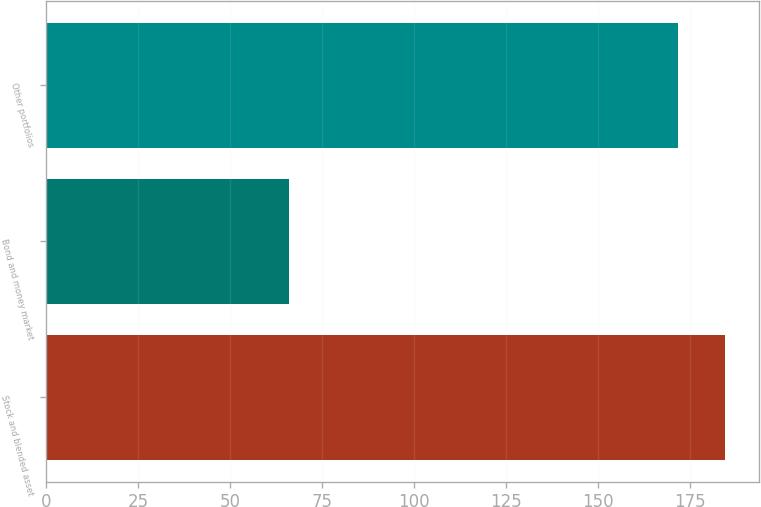Convert chart. <chart><loc_0><loc_0><loc_500><loc_500><bar_chart><fcel>Stock and blended asset<fcel>Bond and money market<fcel>Other portfolios<nl><fcel>184.7<fcel>66.1<fcel>171.8<nl></chart> 